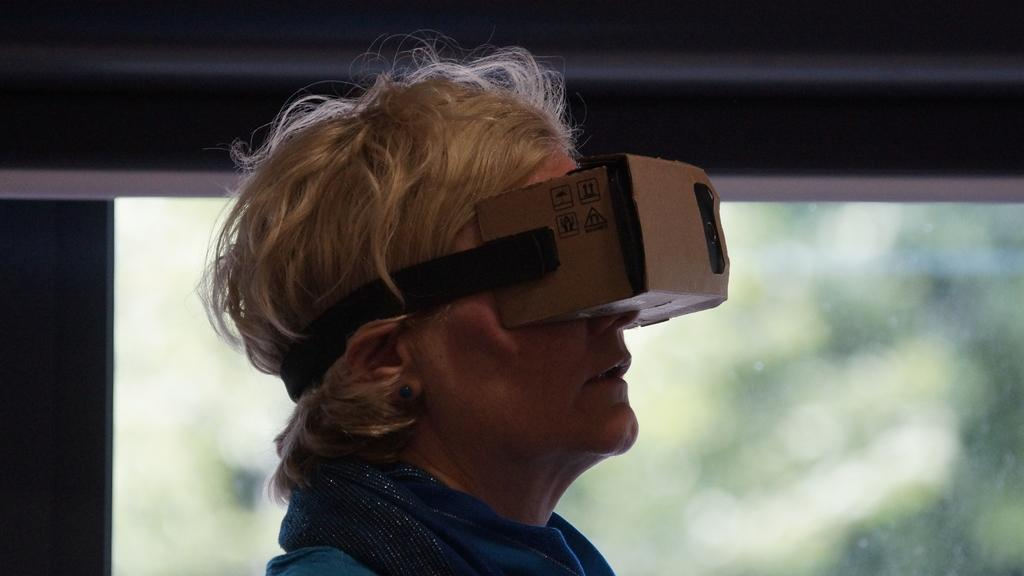What can be seen in the image? There is a person in the image. What is the person wearing? The person is wearing clothes and VR glasses. Can you describe the background of the image? The background of the image is blurred. What language is the person speaking in the image? There is no indication of the person speaking in the image, so it cannot be determined what language they might be using. 